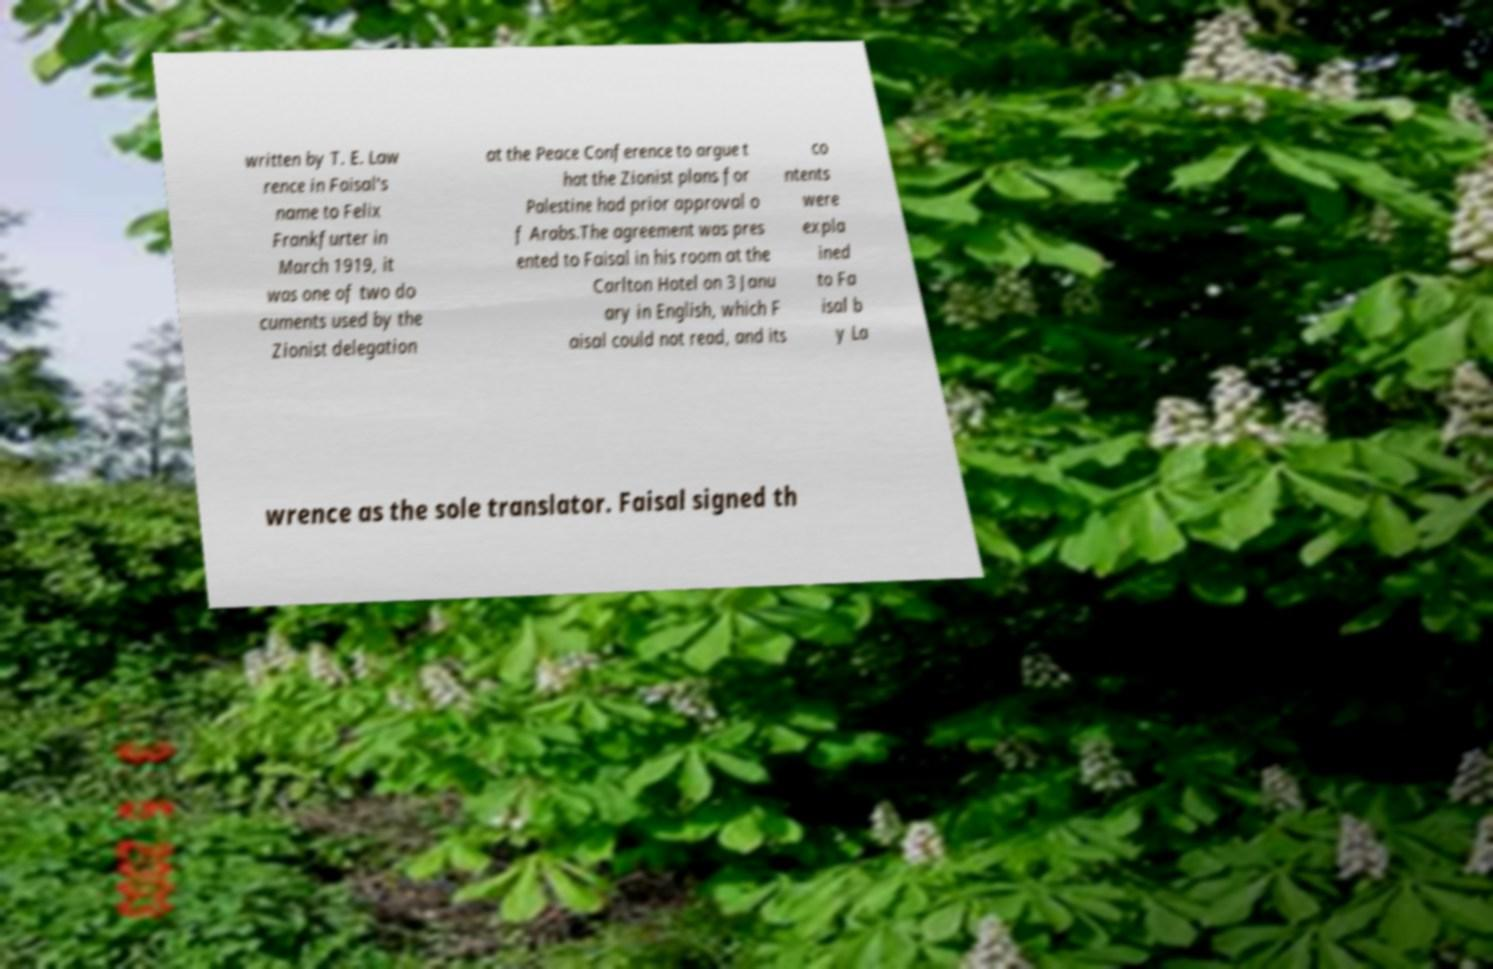Please identify and transcribe the text found in this image. written by T. E. Law rence in Faisal's name to Felix Frankfurter in March 1919, it was one of two do cuments used by the Zionist delegation at the Peace Conference to argue t hat the Zionist plans for Palestine had prior approval o f Arabs.The agreement was pres ented to Faisal in his room at the Carlton Hotel on 3 Janu ary in English, which F aisal could not read, and its co ntents were expla ined to Fa isal b y La wrence as the sole translator. Faisal signed th 